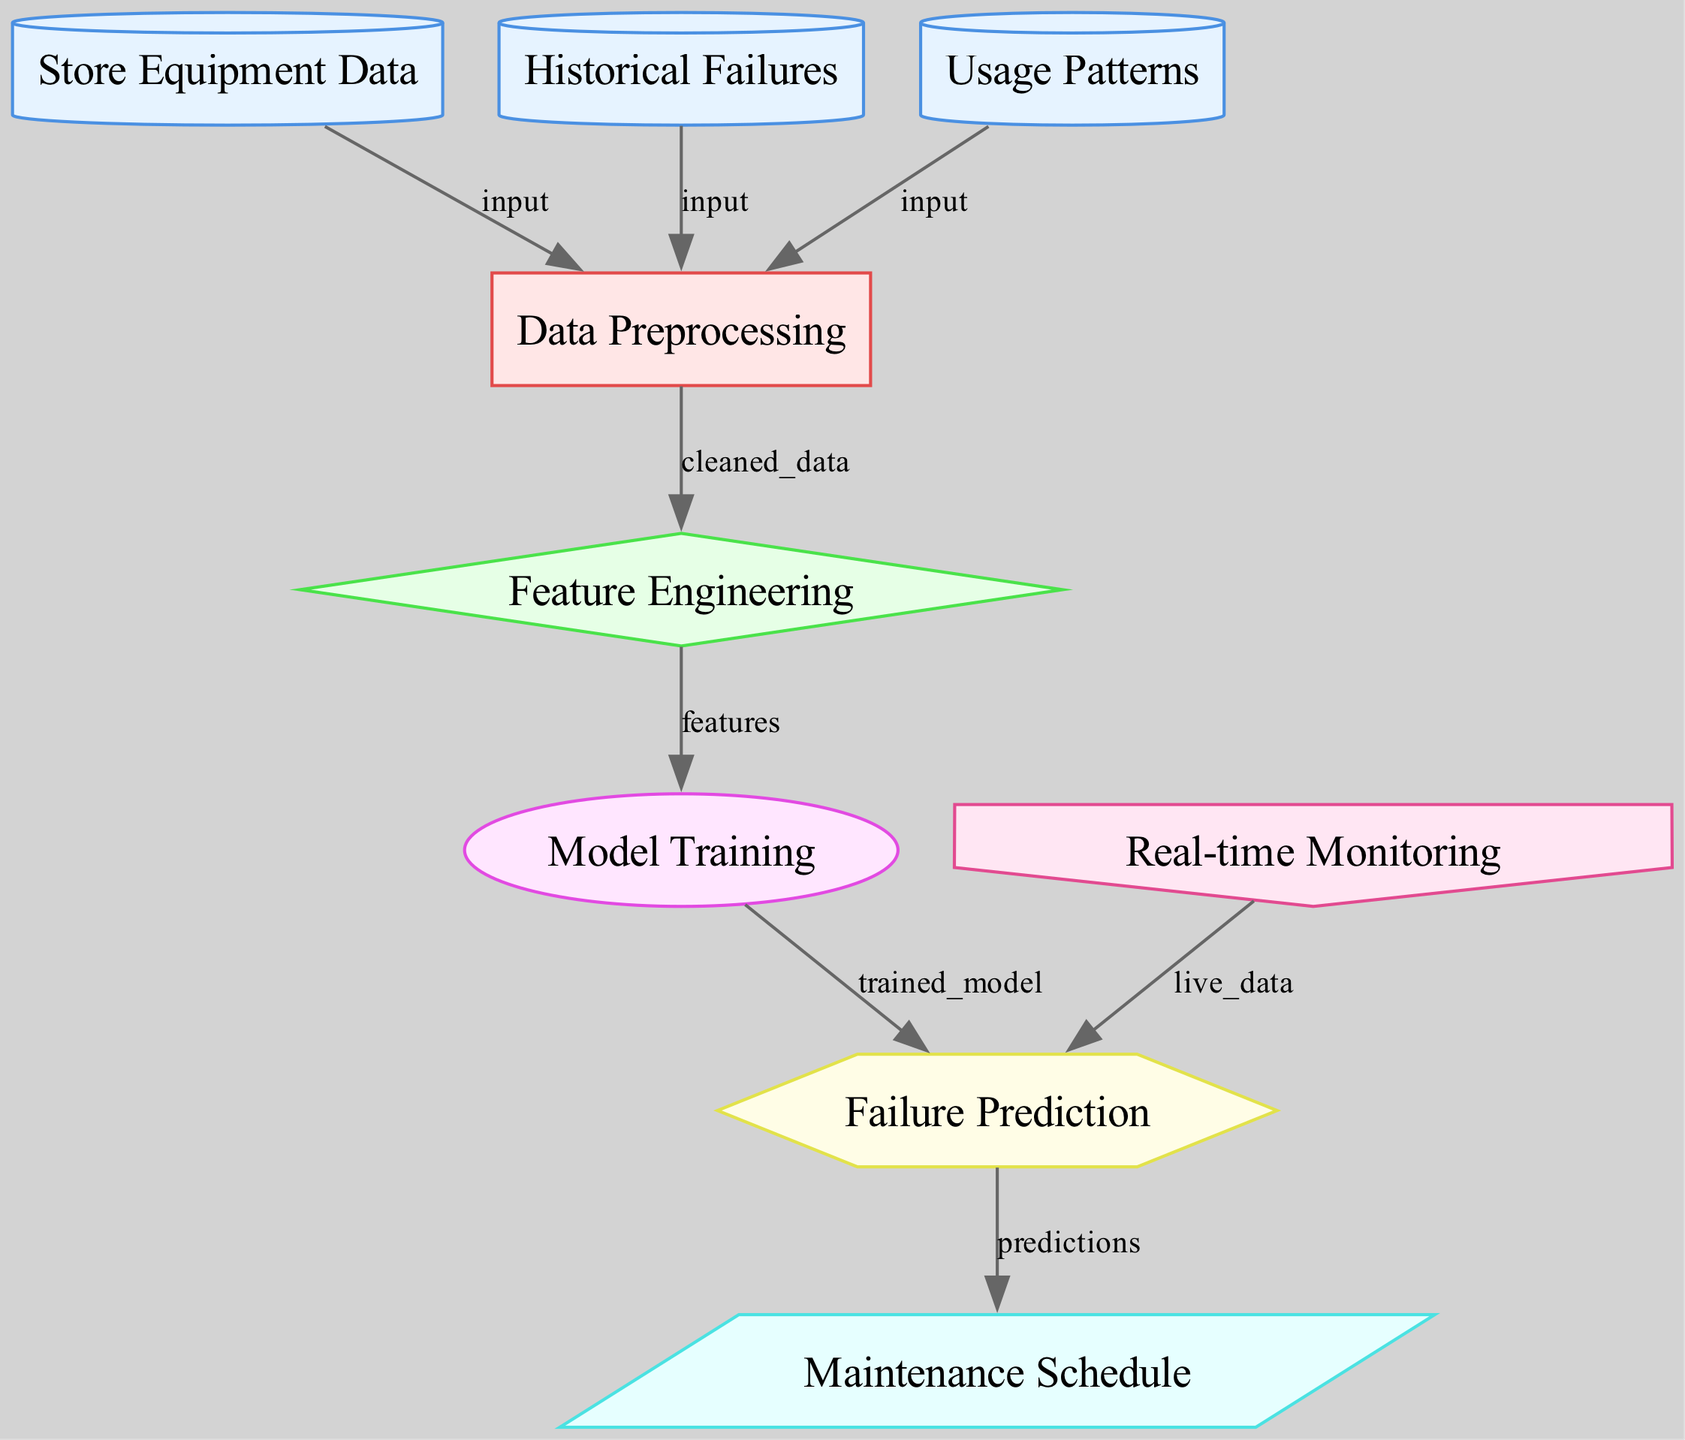What's the total number of nodes in the diagram? The diagram consists of nine distinct nodes related to the predictive maintenance process.
Answer: Nine What type of data source is used for 'usage patterns'? In the diagram, 'usage patterns' is represented as a data source node, indicated specifically by the label 'data_source'.
Answer: Data source Which node follows 'data preprocessing' in the sequence? After 'data preprocessing', the diagram flows into 'feature engineering', indicating the next step in the process.
Answer: Feature engineering How many data sources are there in total? The diagram includes three data sources: 'store equipment data', 'historical failures', and 'usage patterns', making a total of three.
Answer: Three What is the final output of the diagram? The output of the diagram is represented by the 'maintenance schedule', which shows the end result of the predictive maintenance process.
Answer: Maintenance schedule What does the 'failure prediction' node rely on for live data? The 'failure prediction' node receives live data from the 'real-time monitoring' input, allowing it to make up-to-date predictions.
Answer: Real-time monitoring Which node is directly linked to 'maintenance schedule'? The 'maintenance schedule' receives its information directly from the 'failure prediction' node, indicating a one-to-one connection between them.
Answer: Failure prediction What step comes before 'model training'? 'Feature engineering' is the step that comes directly before 'model training,' suggesting the need to extract relevant features beforehand.
Answer: Feature engineering How many edges connect to the 'data preprocessing' node? There are three edges connected to the 'data preprocessing' node, each from the three different data source nodes feeding into it.
Answer: Three 